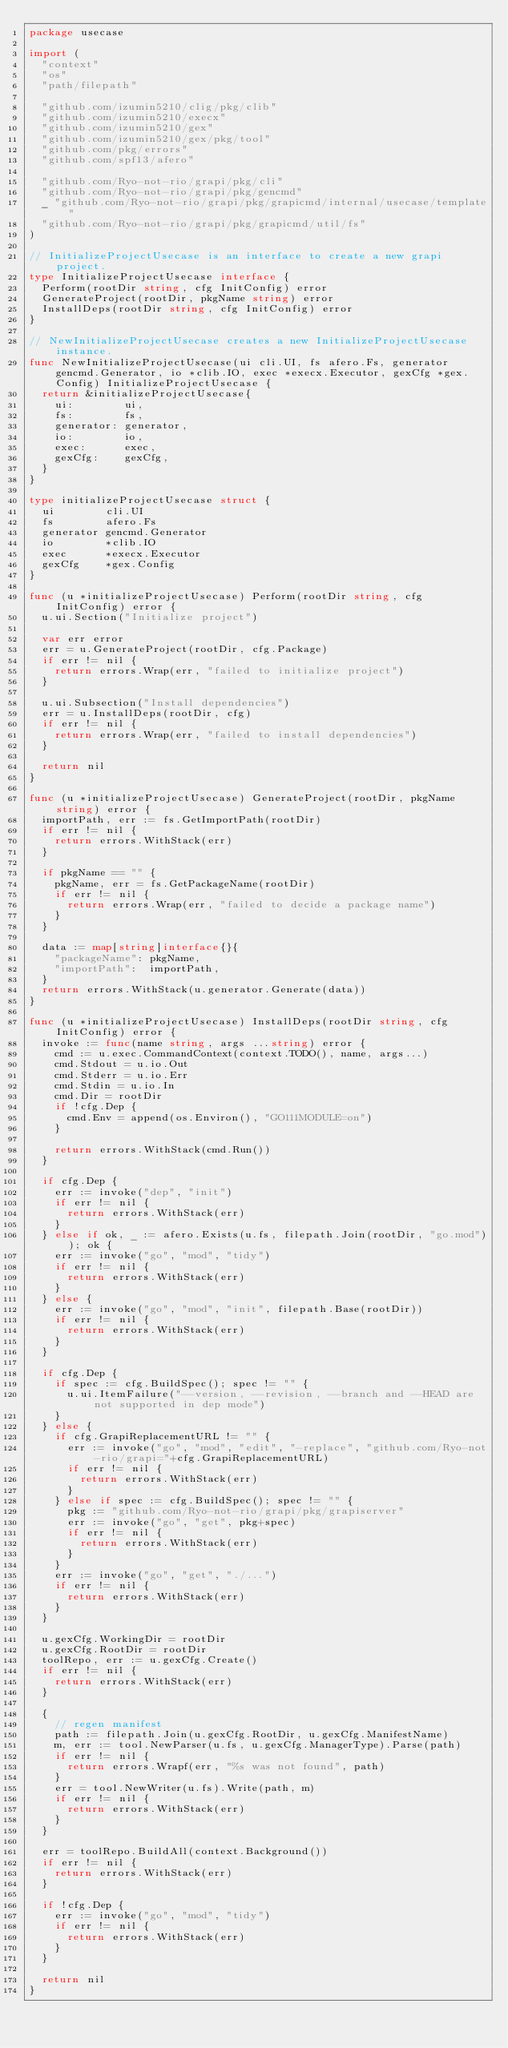Convert code to text. <code><loc_0><loc_0><loc_500><loc_500><_Go_>package usecase

import (
	"context"
	"os"
	"path/filepath"

	"github.com/izumin5210/clig/pkg/clib"
	"github.com/izumin5210/execx"
	"github.com/izumin5210/gex"
	"github.com/izumin5210/gex/pkg/tool"
	"github.com/pkg/errors"
	"github.com/spf13/afero"

	"github.com/Ryo-not-rio/grapi/pkg/cli"
	"github.com/Ryo-not-rio/grapi/pkg/gencmd"
	_ "github.com/Ryo-not-rio/grapi/pkg/grapicmd/internal/usecase/template"
	"github.com/Ryo-not-rio/grapi/pkg/grapicmd/util/fs"
)

// InitializeProjectUsecase is an interface to create a new grapi project.
type InitializeProjectUsecase interface {
	Perform(rootDir string, cfg InitConfig) error
	GenerateProject(rootDir, pkgName string) error
	InstallDeps(rootDir string, cfg InitConfig) error
}

// NewInitializeProjectUsecase creates a new InitializeProjectUsecase instance.
func NewInitializeProjectUsecase(ui cli.UI, fs afero.Fs, generator gencmd.Generator, io *clib.IO, exec *execx.Executor, gexCfg *gex.Config) InitializeProjectUsecase {
	return &initializeProjectUsecase{
		ui:        ui,
		fs:        fs,
		generator: generator,
		io:        io,
		exec:      exec,
		gexCfg:    gexCfg,
	}
}

type initializeProjectUsecase struct {
	ui        cli.UI
	fs        afero.Fs
	generator gencmd.Generator
	io        *clib.IO
	exec      *execx.Executor
	gexCfg    *gex.Config
}

func (u *initializeProjectUsecase) Perform(rootDir string, cfg InitConfig) error {
	u.ui.Section("Initialize project")

	var err error
	err = u.GenerateProject(rootDir, cfg.Package)
	if err != nil {
		return errors.Wrap(err, "failed to initialize project")
	}

	u.ui.Subsection("Install dependencies")
	err = u.InstallDeps(rootDir, cfg)
	if err != nil {
		return errors.Wrap(err, "failed to install dependencies")
	}

	return nil
}

func (u *initializeProjectUsecase) GenerateProject(rootDir, pkgName string) error {
	importPath, err := fs.GetImportPath(rootDir)
	if err != nil {
		return errors.WithStack(err)
	}

	if pkgName == "" {
		pkgName, err = fs.GetPackageName(rootDir)
		if err != nil {
			return errors.Wrap(err, "failed to decide a package name")
		}
	}

	data := map[string]interface{}{
		"packageName": pkgName,
		"importPath":  importPath,
	}
	return errors.WithStack(u.generator.Generate(data))
}

func (u *initializeProjectUsecase) InstallDeps(rootDir string, cfg InitConfig) error {
	invoke := func(name string, args ...string) error {
		cmd := u.exec.CommandContext(context.TODO(), name, args...)
		cmd.Stdout = u.io.Out
		cmd.Stderr = u.io.Err
		cmd.Stdin = u.io.In
		cmd.Dir = rootDir
		if !cfg.Dep {
			cmd.Env = append(os.Environ(), "GO111MODULE=on")
		}

		return errors.WithStack(cmd.Run())
	}

	if cfg.Dep {
		err := invoke("dep", "init")
		if err != nil {
			return errors.WithStack(err)
		}
	} else if ok, _ := afero.Exists(u.fs, filepath.Join(rootDir, "go.mod")); ok {
		err := invoke("go", "mod", "tidy")
		if err != nil {
			return errors.WithStack(err)
		}
	} else {
		err := invoke("go", "mod", "init", filepath.Base(rootDir))
		if err != nil {
			return errors.WithStack(err)
		}
	}

	if cfg.Dep {
		if spec := cfg.BuildSpec(); spec != "" {
			u.ui.ItemFailure("--version, --revision, --branch and --HEAD are not supported in dep mode")
		}
	} else {
		if cfg.GrapiReplacementURL != "" {
			err := invoke("go", "mod", "edit", "-replace", "github.com/Ryo-not-rio/grapi="+cfg.GrapiReplacementURL)
			if err != nil {
				return errors.WithStack(err)
			}
		} else if spec := cfg.BuildSpec(); spec != "" {
			pkg := "github.com/Ryo-not-rio/grapi/pkg/grapiserver"
			err := invoke("go", "get", pkg+spec)
			if err != nil {
				return errors.WithStack(err)
			}
		}
		err := invoke("go", "get", "./...")
		if err != nil {
			return errors.WithStack(err)
		}
	}

	u.gexCfg.WorkingDir = rootDir
	u.gexCfg.RootDir = rootDir
	toolRepo, err := u.gexCfg.Create()
	if err != nil {
		return errors.WithStack(err)
	}

	{
		// regen manifest
		path := filepath.Join(u.gexCfg.RootDir, u.gexCfg.ManifestName)
		m, err := tool.NewParser(u.fs, u.gexCfg.ManagerType).Parse(path)
		if err != nil {
			return errors.Wrapf(err, "%s was not found", path)
		}
		err = tool.NewWriter(u.fs).Write(path, m)
		if err != nil {
			return errors.WithStack(err)
		}
	}

	err = toolRepo.BuildAll(context.Background())
	if err != nil {
		return errors.WithStack(err)
	}

	if !cfg.Dep {
		err := invoke("go", "mod", "tidy")
		if err != nil {
			return errors.WithStack(err)
		}
	}

	return nil
}
</code> 